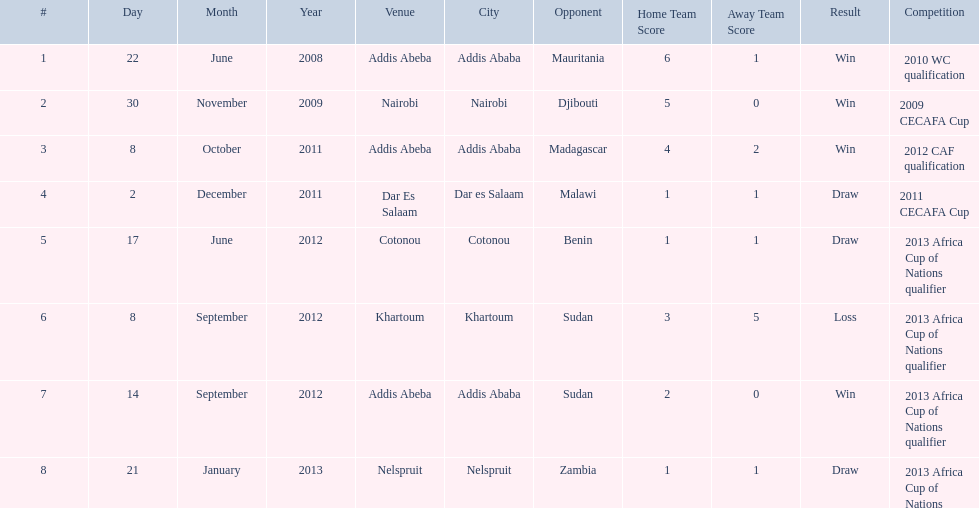For each winning game, what was their score? 6-1, 5-0, 4-2, 2-0. 